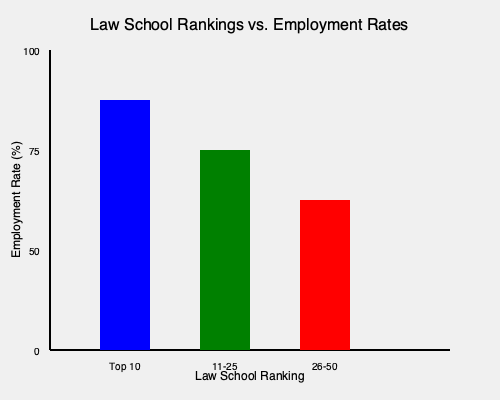Based on the bar graph comparing law school rankings and employment rates, what is the approximate difference in employment rates between Top 10 law schools and schools ranked 26-50? To find the difference in employment rates between Top 10 law schools and those ranked 26-50, we need to:

1. Estimate the employment rate for Top 10 schools:
   - The blue bar represents Top 10 schools
   - It reaches approximately 87.5% on the y-axis

2. Estimate the employment rate for schools ranked 26-50:
   - The red bar represents schools ranked 26-50
   - It reaches approximately 62.5% on the y-axis

3. Calculate the difference:
   $87.5\% - 62.5\% = 25\%$

Therefore, the approximate difference in employment rates between Top 10 law schools and those ranked 26-50 is 25 percentage points.
Answer: 25 percentage points 